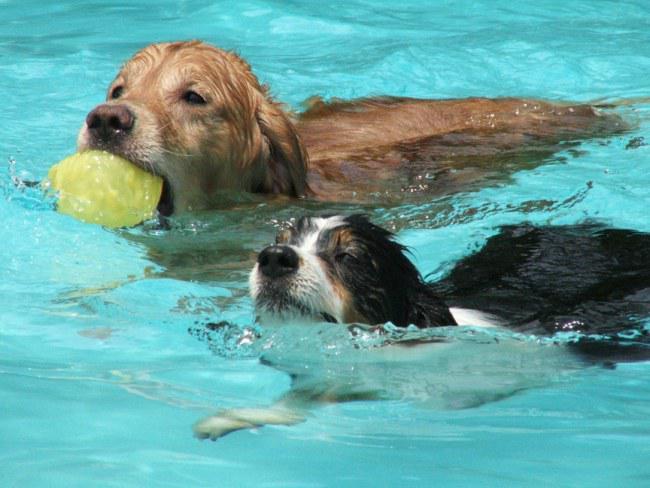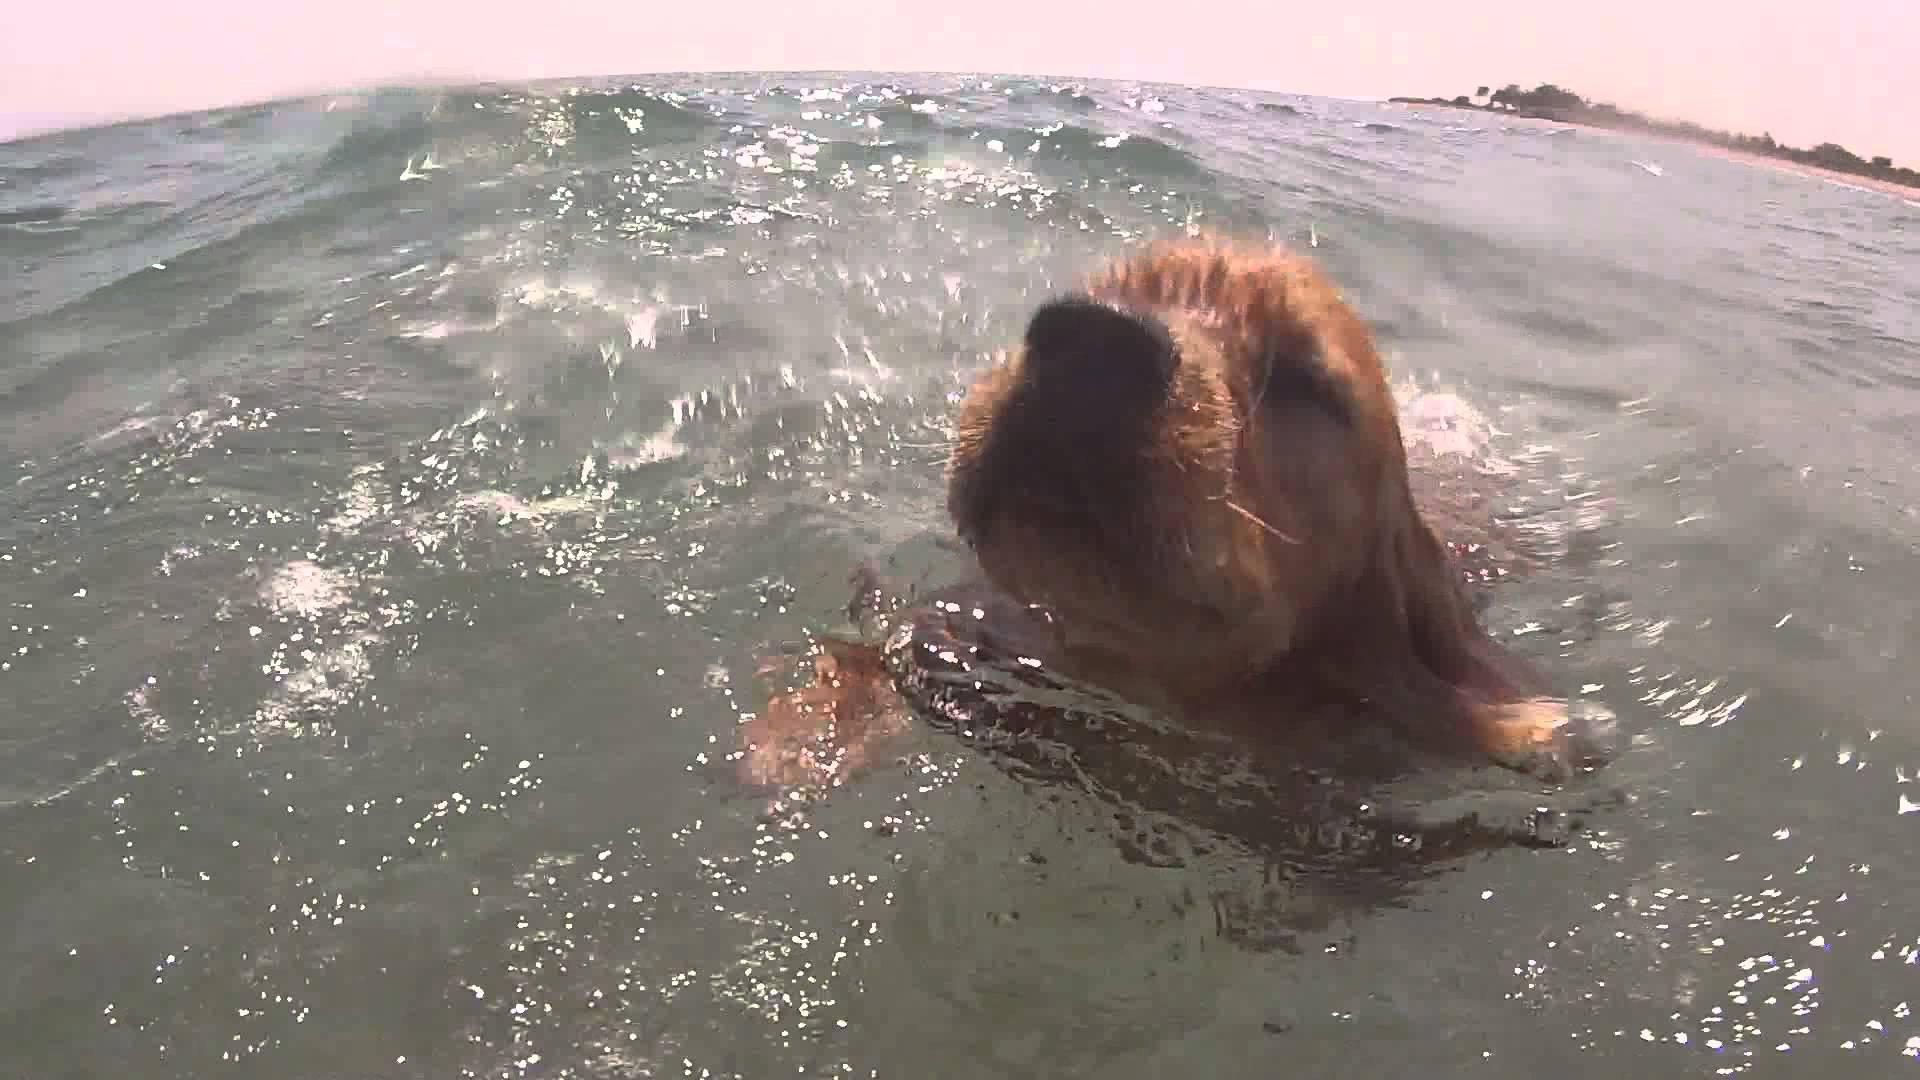The first image is the image on the left, the second image is the image on the right. Analyze the images presented: Is the assertion "In one of the images there are at least three dogs swimming" valid? Answer yes or no. No. The first image is the image on the left, the second image is the image on the right. Given the left and right images, does the statement "One image shows at least three spaniel dogs swimming horizontally in the same direction across a swimming pool." hold true? Answer yes or no. No. 